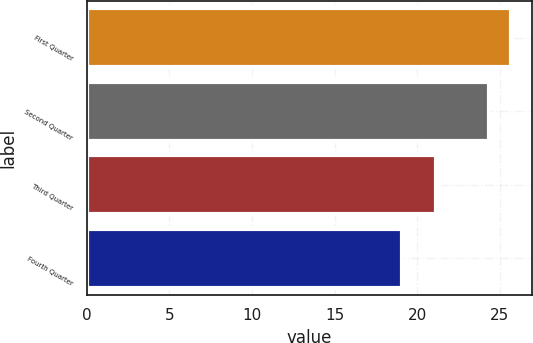<chart> <loc_0><loc_0><loc_500><loc_500><bar_chart><fcel>First Quarter<fcel>Second Quarter<fcel>Third Quarter<fcel>Fourth Quarter<nl><fcel>25.65<fcel>24.34<fcel>21.16<fcel>19.06<nl></chart> 